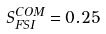Convert formula to latex. <formula><loc_0><loc_0><loc_500><loc_500>S ^ { C O M } _ { F S I } = 0 . 2 5</formula> 